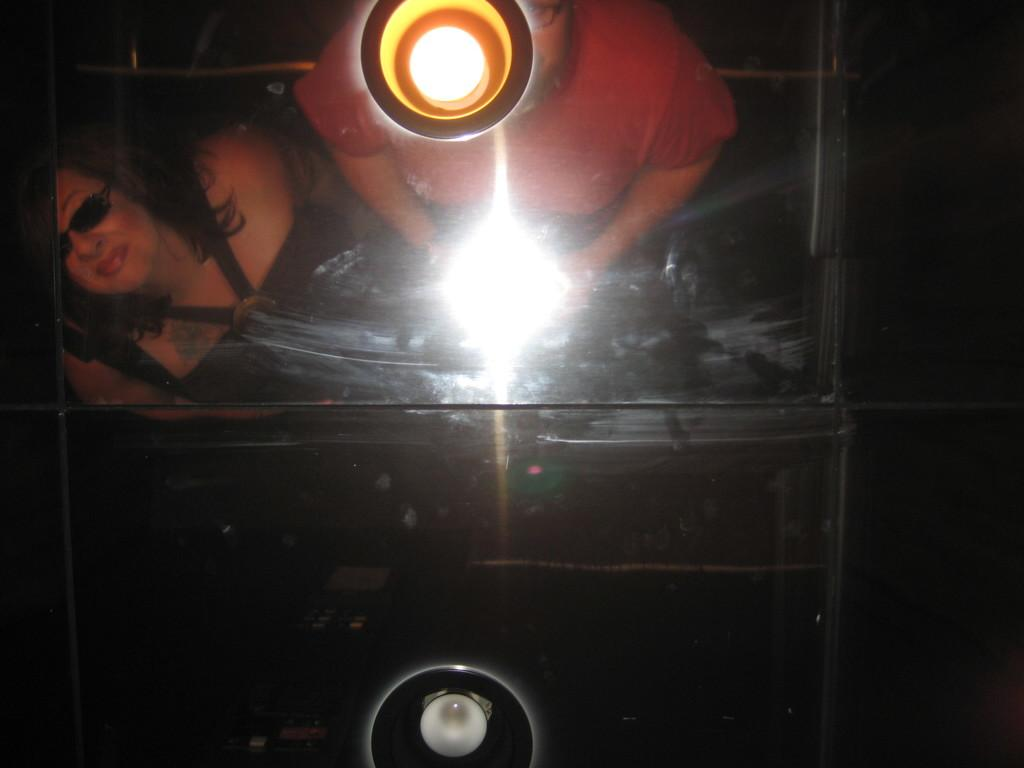What type of vehicle is visible in the image? There is a vehicle with lights in the image. How many people are inside the vehicle? There are two persons in the vehicle. What can be observed about the background of the image? The background of the image is dark. What type of connection can be seen between the two persons in the vehicle? There is no specific connection visible between the two persons in the vehicle; they are simply sitting inside the vehicle. 